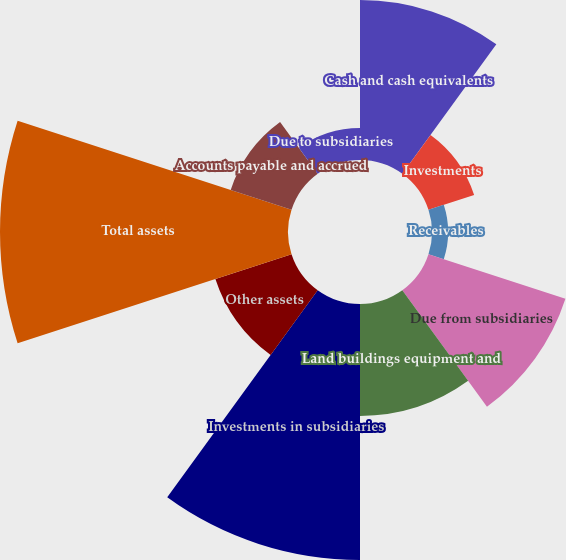<chart> <loc_0><loc_0><loc_500><loc_500><pie_chart><fcel>Cash and cash equivalents<fcel>Investments<fcel>Receivables<fcel>Due from subsidiaries<fcel>Land buildings equipment and<fcel>Investments in subsidiaries<fcel>Other assets<fcel>Total assets<fcel>Accounts payable and accrued<fcel>Due to subsidiaries<nl><fcel>13.33%<fcel>4.0%<fcel>1.34%<fcel>12.0%<fcel>9.33%<fcel>21.33%<fcel>6.67%<fcel>24.0%<fcel>5.33%<fcel>2.67%<nl></chart> 